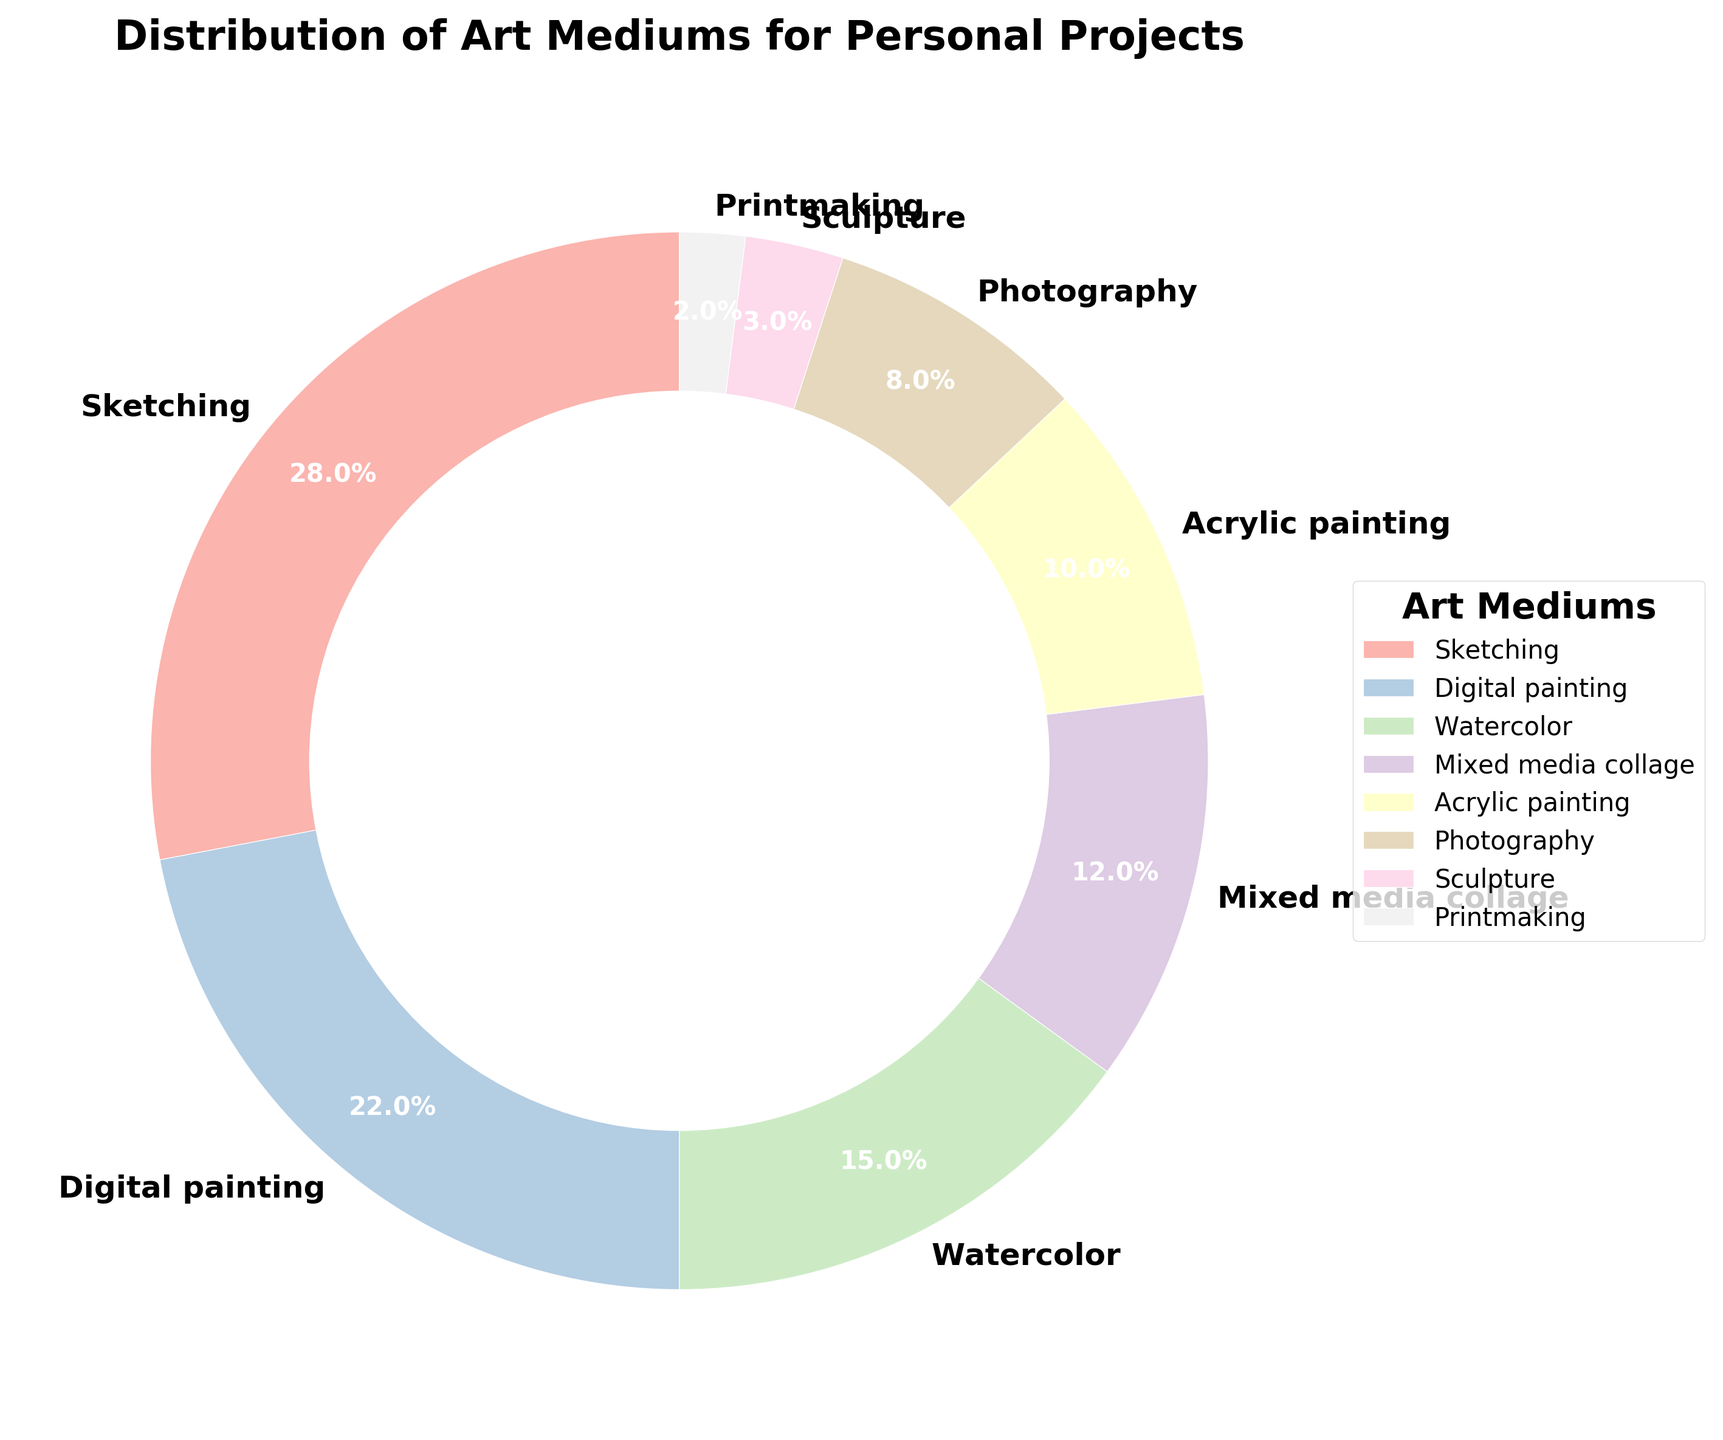Which medium has the highest percentage of usage? By looking at the pie chart, the section with the largest size and the label indicating the highest percentage will identify the most used medium.
Answer: Sketching How much larger is the percentage of Sketching compared to Sculpture? Sketching is 28% and Sculpture is 3%. The difference is found by subtracting the percentages: 28% - 3%.
Answer: 25% Which medium has the lowest percentage of usage? By finding the smallest segment in the pie chart and checking its label, we identify the medium with the lowest percentage.
Answer: Printmaking What is the combined percentage of usage for Acrylic painting and Photography? Add the percentages of Acrylic painting (10%) and Photography (8%): 10% + 8%.
Answer: 18% How does the usage of Digital painting compare to Watercolor? Compare the given percentages of Digital painting (22%) and Watercolor (15%). Since 22% is greater than 15%, Digital painting is more used.
Answer: Digital painting is more used How many mediums have a usage rate that is less than 10%? Identify and count the segments in the pie chart labeled with percentages less than 10%. These are Photography (8%), Sculpture (3%), and Printmaking (2%).
Answer: 3 What is the difference in percentage points between Mixed media collage and Acrylic painting? Mixed media collage is 12% and Acrylic painting is 10%. The difference is calculated as 12% - 10%.
Answer: 2% What percentage of mediums are used together by Watercolor and Acrylic painting? Sum the percentages of Watercolor (15%) and Acrylic painting (10%): 15% + 10%.
Answer: 25% Which color represents the medium with the highest usage? Identify the color used for the largest segment, which represents Sketching (28%). The color used will be mentioned in the chart legend or directly visible.
Answer: The color representing Sketching (exact color varies depending on chart) How does Mixed media collage's usage compare to the combined usage of Sculpture and Printmaking? The percentage for Mixed media collage is 12%. Sculpture (3%) and Printmaking (2%) together sum up to 5%. Comparatively, 12% (Mixed media collage) is greater than 5% (Sculpture + Printmaking).
Answer: Mixed media collage is more used 